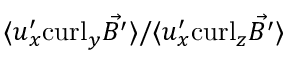Convert formula to latex. <formula><loc_0><loc_0><loc_500><loc_500>\langle { u } _ { x } ^ { \prime } c u r l _ { y } \vec { B ^ { \prime } } \rangle / \langle { u } _ { x } ^ { \prime } c u r l _ { z } \vec { B ^ { \prime } } \rangle</formula> 